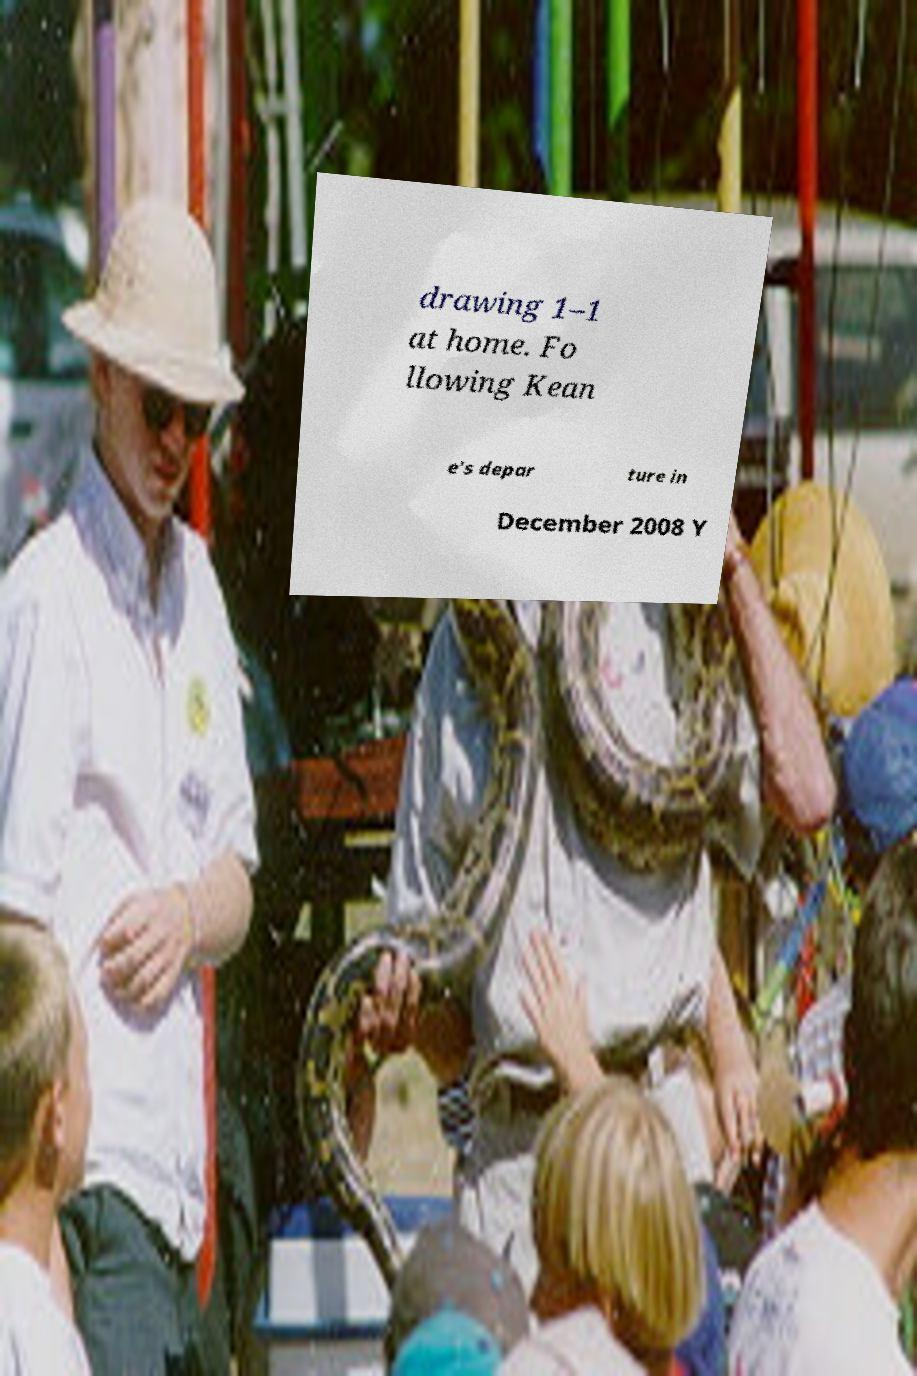Could you extract and type out the text from this image? drawing 1–1 at home. Fo llowing Kean e's depar ture in December 2008 Y 